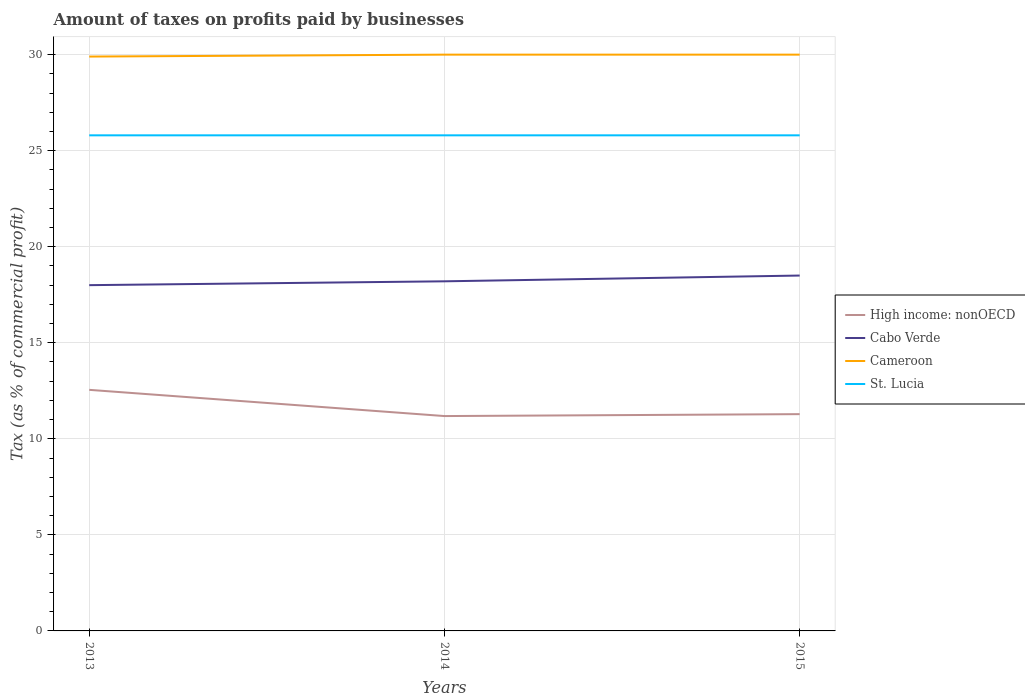How many different coloured lines are there?
Ensure brevity in your answer.  4. Is the number of lines equal to the number of legend labels?
Your answer should be compact. Yes. Across all years, what is the maximum percentage of taxes paid by businesses in Cabo Verde?
Your response must be concise. 18. In which year was the percentage of taxes paid by businesses in High income: nonOECD maximum?
Make the answer very short. 2014. What is the total percentage of taxes paid by businesses in High income: nonOECD in the graph?
Ensure brevity in your answer.  1.36. Is the percentage of taxes paid by businesses in Cameroon strictly greater than the percentage of taxes paid by businesses in High income: nonOECD over the years?
Provide a short and direct response. No. How many lines are there?
Your answer should be compact. 4. Does the graph contain grids?
Offer a terse response. Yes. What is the title of the graph?
Keep it short and to the point. Amount of taxes on profits paid by businesses. Does "Chad" appear as one of the legend labels in the graph?
Offer a very short reply. No. What is the label or title of the X-axis?
Offer a very short reply. Years. What is the label or title of the Y-axis?
Keep it short and to the point. Tax (as % of commercial profit). What is the Tax (as % of commercial profit) in High income: nonOECD in 2013?
Your answer should be compact. 12.55. What is the Tax (as % of commercial profit) in Cameroon in 2013?
Offer a terse response. 29.9. What is the Tax (as % of commercial profit) in St. Lucia in 2013?
Make the answer very short. 25.8. What is the Tax (as % of commercial profit) in High income: nonOECD in 2014?
Your answer should be compact. 11.19. What is the Tax (as % of commercial profit) of Cameroon in 2014?
Make the answer very short. 30. What is the Tax (as % of commercial profit) in St. Lucia in 2014?
Give a very brief answer. 25.8. What is the Tax (as % of commercial profit) of High income: nonOECD in 2015?
Keep it short and to the point. 11.29. What is the Tax (as % of commercial profit) in St. Lucia in 2015?
Give a very brief answer. 25.8. Across all years, what is the maximum Tax (as % of commercial profit) of High income: nonOECD?
Keep it short and to the point. 12.55. Across all years, what is the maximum Tax (as % of commercial profit) of Cameroon?
Provide a short and direct response. 30. Across all years, what is the maximum Tax (as % of commercial profit) in St. Lucia?
Offer a terse response. 25.8. Across all years, what is the minimum Tax (as % of commercial profit) in High income: nonOECD?
Provide a succinct answer. 11.19. Across all years, what is the minimum Tax (as % of commercial profit) in Cameroon?
Ensure brevity in your answer.  29.9. Across all years, what is the minimum Tax (as % of commercial profit) in St. Lucia?
Your response must be concise. 25.8. What is the total Tax (as % of commercial profit) in High income: nonOECD in the graph?
Keep it short and to the point. 35.02. What is the total Tax (as % of commercial profit) of Cabo Verde in the graph?
Your response must be concise. 54.7. What is the total Tax (as % of commercial profit) of Cameroon in the graph?
Offer a terse response. 89.9. What is the total Tax (as % of commercial profit) in St. Lucia in the graph?
Offer a very short reply. 77.4. What is the difference between the Tax (as % of commercial profit) in High income: nonOECD in 2013 and that in 2014?
Your response must be concise. 1.36. What is the difference between the Tax (as % of commercial profit) of Cameroon in 2013 and that in 2014?
Provide a short and direct response. -0.1. What is the difference between the Tax (as % of commercial profit) in High income: nonOECD in 2013 and that in 2015?
Provide a succinct answer. 1.26. What is the difference between the Tax (as % of commercial profit) in Cabo Verde in 2014 and that in 2015?
Offer a very short reply. -0.3. What is the difference between the Tax (as % of commercial profit) in St. Lucia in 2014 and that in 2015?
Ensure brevity in your answer.  0. What is the difference between the Tax (as % of commercial profit) of High income: nonOECD in 2013 and the Tax (as % of commercial profit) of Cabo Verde in 2014?
Your answer should be compact. -5.65. What is the difference between the Tax (as % of commercial profit) in High income: nonOECD in 2013 and the Tax (as % of commercial profit) in Cameroon in 2014?
Provide a succinct answer. -17.45. What is the difference between the Tax (as % of commercial profit) of High income: nonOECD in 2013 and the Tax (as % of commercial profit) of St. Lucia in 2014?
Give a very brief answer. -13.25. What is the difference between the Tax (as % of commercial profit) in Cabo Verde in 2013 and the Tax (as % of commercial profit) in Cameroon in 2014?
Give a very brief answer. -12. What is the difference between the Tax (as % of commercial profit) in Cameroon in 2013 and the Tax (as % of commercial profit) in St. Lucia in 2014?
Provide a short and direct response. 4.1. What is the difference between the Tax (as % of commercial profit) in High income: nonOECD in 2013 and the Tax (as % of commercial profit) in Cabo Verde in 2015?
Ensure brevity in your answer.  -5.95. What is the difference between the Tax (as % of commercial profit) in High income: nonOECD in 2013 and the Tax (as % of commercial profit) in Cameroon in 2015?
Your answer should be compact. -17.45. What is the difference between the Tax (as % of commercial profit) in High income: nonOECD in 2013 and the Tax (as % of commercial profit) in St. Lucia in 2015?
Provide a succinct answer. -13.25. What is the difference between the Tax (as % of commercial profit) in Cabo Verde in 2013 and the Tax (as % of commercial profit) in Cameroon in 2015?
Make the answer very short. -12. What is the difference between the Tax (as % of commercial profit) of Cabo Verde in 2013 and the Tax (as % of commercial profit) of St. Lucia in 2015?
Keep it short and to the point. -7.8. What is the difference between the Tax (as % of commercial profit) of High income: nonOECD in 2014 and the Tax (as % of commercial profit) of Cabo Verde in 2015?
Offer a very short reply. -7.31. What is the difference between the Tax (as % of commercial profit) of High income: nonOECD in 2014 and the Tax (as % of commercial profit) of Cameroon in 2015?
Keep it short and to the point. -18.81. What is the difference between the Tax (as % of commercial profit) in High income: nonOECD in 2014 and the Tax (as % of commercial profit) in St. Lucia in 2015?
Offer a terse response. -14.61. What is the difference between the Tax (as % of commercial profit) of Cabo Verde in 2014 and the Tax (as % of commercial profit) of Cameroon in 2015?
Provide a short and direct response. -11.8. What is the difference between the Tax (as % of commercial profit) of Cabo Verde in 2014 and the Tax (as % of commercial profit) of St. Lucia in 2015?
Give a very brief answer. -7.6. What is the difference between the Tax (as % of commercial profit) of Cameroon in 2014 and the Tax (as % of commercial profit) of St. Lucia in 2015?
Keep it short and to the point. 4.2. What is the average Tax (as % of commercial profit) in High income: nonOECD per year?
Provide a succinct answer. 11.67. What is the average Tax (as % of commercial profit) of Cabo Verde per year?
Ensure brevity in your answer.  18.23. What is the average Tax (as % of commercial profit) of Cameroon per year?
Offer a very short reply. 29.97. What is the average Tax (as % of commercial profit) in St. Lucia per year?
Give a very brief answer. 25.8. In the year 2013, what is the difference between the Tax (as % of commercial profit) in High income: nonOECD and Tax (as % of commercial profit) in Cabo Verde?
Offer a terse response. -5.45. In the year 2013, what is the difference between the Tax (as % of commercial profit) of High income: nonOECD and Tax (as % of commercial profit) of Cameroon?
Give a very brief answer. -17.35. In the year 2013, what is the difference between the Tax (as % of commercial profit) of High income: nonOECD and Tax (as % of commercial profit) of St. Lucia?
Give a very brief answer. -13.25. In the year 2013, what is the difference between the Tax (as % of commercial profit) in Cabo Verde and Tax (as % of commercial profit) in Cameroon?
Offer a terse response. -11.9. In the year 2013, what is the difference between the Tax (as % of commercial profit) of Cameroon and Tax (as % of commercial profit) of St. Lucia?
Make the answer very short. 4.1. In the year 2014, what is the difference between the Tax (as % of commercial profit) in High income: nonOECD and Tax (as % of commercial profit) in Cabo Verde?
Ensure brevity in your answer.  -7.01. In the year 2014, what is the difference between the Tax (as % of commercial profit) in High income: nonOECD and Tax (as % of commercial profit) in Cameroon?
Offer a very short reply. -18.81. In the year 2014, what is the difference between the Tax (as % of commercial profit) of High income: nonOECD and Tax (as % of commercial profit) of St. Lucia?
Provide a succinct answer. -14.61. In the year 2014, what is the difference between the Tax (as % of commercial profit) of Cabo Verde and Tax (as % of commercial profit) of Cameroon?
Ensure brevity in your answer.  -11.8. In the year 2014, what is the difference between the Tax (as % of commercial profit) of Cabo Verde and Tax (as % of commercial profit) of St. Lucia?
Make the answer very short. -7.6. In the year 2014, what is the difference between the Tax (as % of commercial profit) of Cameroon and Tax (as % of commercial profit) of St. Lucia?
Your answer should be very brief. 4.2. In the year 2015, what is the difference between the Tax (as % of commercial profit) of High income: nonOECD and Tax (as % of commercial profit) of Cabo Verde?
Offer a very short reply. -7.21. In the year 2015, what is the difference between the Tax (as % of commercial profit) of High income: nonOECD and Tax (as % of commercial profit) of Cameroon?
Your answer should be very brief. -18.71. In the year 2015, what is the difference between the Tax (as % of commercial profit) of High income: nonOECD and Tax (as % of commercial profit) of St. Lucia?
Give a very brief answer. -14.51. In the year 2015, what is the difference between the Tax (as % of commercial profit) of Cameroon and Tax (as % of commercial profit) of St. Lucia?
Make the answer very short. 4.2. What is the ratio of the Tax (as % of commercial profit) in High income: nonOECD in 2013 to that in 2014?
Offer a terse response. 1.12. What is the ratio of the Tax (as % of commercial profit) in Cabo Verde in 2013 to that in 2014?
Ensure brevity in your answer.  0.99. What is the ratio of the Tax (as % of commercial profit) in St. Lucia in 2013 to that in 2014?
Make the answer very short. 1. What is the ratio of the Tax (as % of commercial profit) of High income: nonOECD in 2013 to that in 2015?
Make the answer very short. 1.11. What is the ratio of the Tax (as % of commercial profit) in Cabo Verde in 2013 to that in 2015?
Your answer should be very brief. 0.97. What is the ratio of the Tax (as % of commercial profit) in Cameroon in 2013 to that in 2015?
Offer a terse response. 1. What is the ratio of the Tax (as % of commercial profit) in High income: nonOECD in 2014 to that in 2015?
Keep it short and to the point. 0.99. What is the ratio of the Tax (as % of commercial profit) in Cabo Verde in 2014 to that in 2015?
Your answer should be very brief. 0.98. What is the ratio of the Tax (as % of commercial profit) of St. Lucia in 2014 to that in 2015?
Offer a very short reply. 1. What is the difference between the highest and the second highest Tax (as % of commercial profit) of High income: nonOECD?
Give a very brief answer. 1.26. What is the difference between the highest and the second highest Tax (as % of commercial profit) of Cameroon?
Your answer should be compact. 0. What is the difference between the highest and the lowest Tax (as % of commercial profit) of High income: nonOECD?
Your response must be concise. 1.36. What is the difference between the highest and the lowest Tax (as % of commercial profit) in Cameroon?
Provide a short and direct response. 0.1. What is the difference between the highest and the lowest Tax (as % of commercial profit) of St. Lucia?
Keep it short and to the point. 0. 